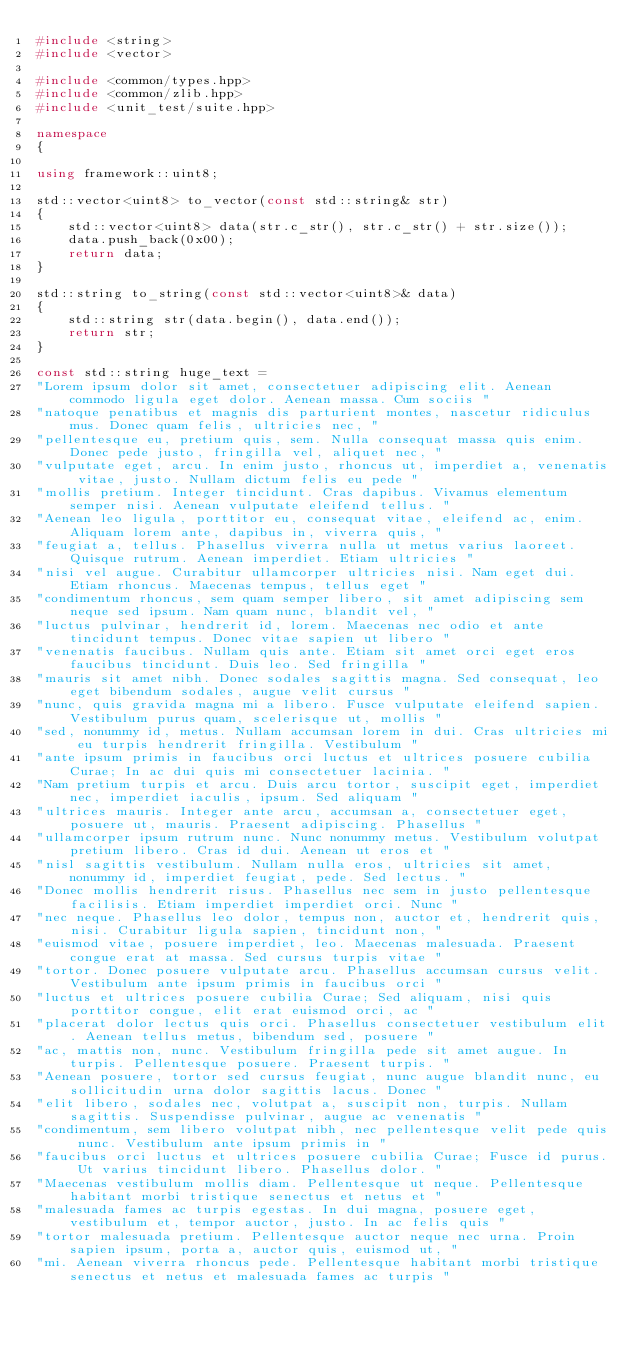<code> <loc_0><loc_0><loc_500><loc_500><_C++_>#include <string>
#include <vector>

#include <common/types.hpp>
#include <common/zlib.hpp>
#include <unit_test/suite.hpp>

namespace
{

using framework::uint8;

std::vector<uint8> to_vector(const std::string& str)
{
    std::vector<uint8> data(str.c_str(), str.c_str() + str.size());
    data.push_back(0x00);
    return data;
}

std::string to_string(const std::vector<uint8>& data)
{
    std::string str(data.begin(), data.end());
    return str;
}

const std::string huge_text =
"Lorem ipsum dolor sit amet, consectetuer adipiscing elit. Aenean commodo ligula eget dolor. Aenean massa. Cum sociis "
"natoque penatibus et magnis dis parturient montes, nascetur ridiculus mus. Donec quam felis, ultricies nec, "
"pellentesque eu, pretium quis, sem. Nulla consequat massa quis enim. Donec pede justo, fringilla vel, aliquet nec, "
"vulputate eget, arcu. In enim justo, rhoncus ut, imperdiet a, venenatis vitae, justo. Nullam dictum felis eu pede "
"mollis pretium. Integer tincidunt. Cras dapibus. Vivamus elementum semper nisi. Aenean vulputate eleifend tellus. "
"Aenean leo ligula, porttitor eu, consequat vitae, eleifend ac, enim. Aliquam lorem ante, dapibus in, viverra quis, "
"feugiat a, tellus. Phasellus viverra nulla ut metus varius laoreet. Quisque rutrum. Aenean imperdiet. Etiam ultricies "
"nisi vel augue. Curabitur ullamcorper ultricies nisi. Nam eget dui. Etiam rhoncus. Maecenas tempus, tellus eget "
"condimentum rhoncus, sem quam semper libero, sit amet adipiscing sem neque sed ipsum. Nam quam nunc, blandit vel, "
"luctus pulvinar, hendrerit id, lorem. Maecenas nec odio et ante tincidunt tempus. Donec vitae sapien ut libero "
"venenatis faucibus. Nullam quis ante. Etiam sit amet orci eget eros faucibus tincidunt. Duis leo. Sed fringilla "
"mauris sit amet nibh. Donec sodales sagittis magna. Sed consequat, leo eget bibendum sodales, augue velit cursus "
"nunc, quis gravida magna mi a libero. Fusce vulputate eleifend sapien. Vestibulum purus quam, scelerisque ut, mollis "
"sed, nonummy id, metus. Nullam accumsan lorem in dui. Cras ultricies mi eu turpis hendrerit fringilla. Vestibulum "
"ante ipsum primis in faucibus orci luctus et ultrices posuere cubilia Curae; In ac dui quis mi consectetuer lacinia. "
"Nam pretium turpis et arcu. Duis arcu tortor, suscipit eget, imperdiet nec, imperdiet iaculis, ipsum. Sed aliquam "
"ultrices mauris. Integer ante arcu, accumsan a, consectetuer eget, posuere ut, mauris. Praesent adipiscing. Phasellus "
"ullamcorper ipsum rutrum nunc. Nunc nonummy metus. Vestibulum volutpat pretium libero. Cras id dui. Aenean ut eros et "
"nisl sagittis vestibulum. Nullam nulla eros, ultricies sit amet, nonummy id, imperdiet feugiat, pede. Sed lectus. "
"Donec mollis hendrerit risus. Phasellus nec sem in justo pellentesque facilisis. Etiam imperdiet imperdiet orci. Nunc "
"nec neque. Phasellus leo dolor, tempus non, auctor et, hendrerit quis, nisi. Curabitur ligula sapien, tincidunt non, "
"euismod vitae, posuere imperdiet, leo. Maecenas malesuada. Praesent congue erat at massa. Sed cursus turpis vitae "
"tortor. Donec posuere vulputate arcu. Phasellus accumsan cursus velit. Vestibulum ante ipsum primis in faucibus orci "
"luctus et ultrices posuere cubilia Curae; Sed aliquam, nisi quis porttitor congue, elit erat euismod orci, ac "
"placerat dolor lectus quis orci. Phasellus consectetuer vestibulum elit. Aenean tellus metus, bibendum sed, posuere "
"ac, mattis non, nunc. Vestibulum fringilla pede sit amet augue. In turpis. Pellentesque posuere. Praesent turpis. "
"Aenean posuere, tortor sed cursus feugiat, nunc augue blandit nunc, eu sollicitudin urna dolor sagittis lacus. Donec "
"elit libero, sodales nec, volutpat a, suscipit non, turpis. Nullam sagittis. Suspendisse pulvinar, augue ac venenatis "
"condimentum, sem libero volutpat nibh, nec pellentesque velit pede quis nunc. Vestibulum ante ipsum primis in "
"faucibus orci luctus et ultrices posuere cubilia Curae; Fusce id purus. Ut varius tincidunt libero. Phasellus dolor. "
"Maecenas vestibulum mollis diam. Pellentesque ut neque. Pellentesque habitant morbi tristique senectus et netus et "
"malesuada fames ac turpis egestas. In dui magna, posuere eget, vestibulum et, tempor auctor, justo. In ac felis quis "
"tortor malesuada pretium. Pellentesque auctor neque nec urna. Proin sapien ipsum, porta a, auctor quis, euismod ut, "
"mi. Aenean viverra rhoncus pede. Pellentesque habitant morbi tristique senectus et netus et malesuada fames ac turpis "</code> 